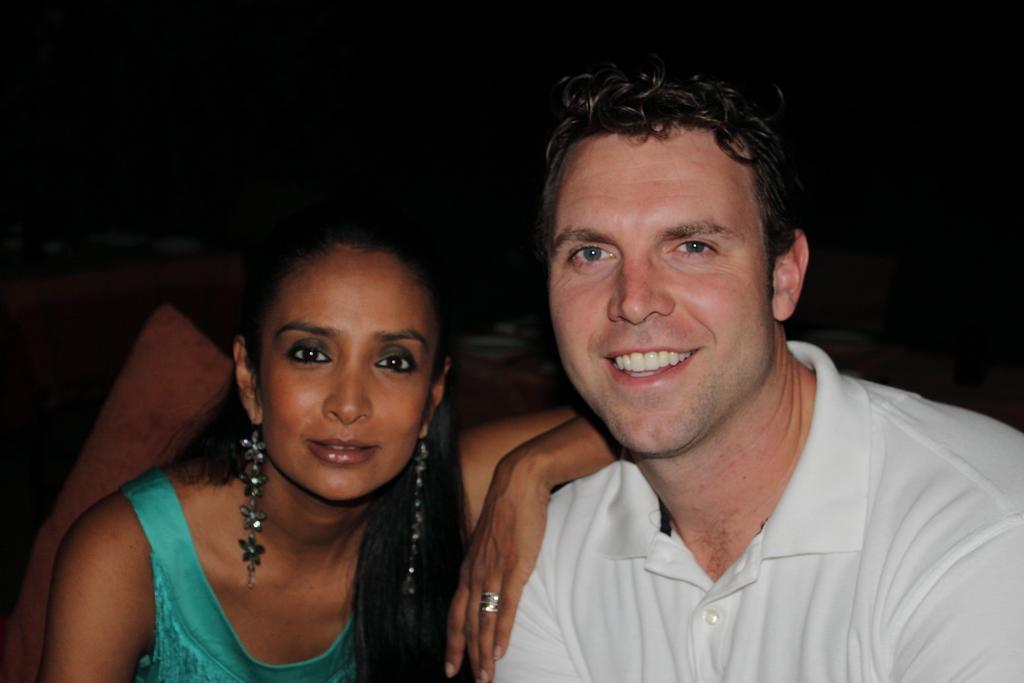Describe this image in one or two sentences. In this image I can see two people are wearing white and blue color dresses. Background is dark. 